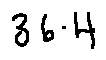Convert formula to latex. <formula><loc_0><loc_0><loc_500><loc_500>3 6 . 4</formula> 